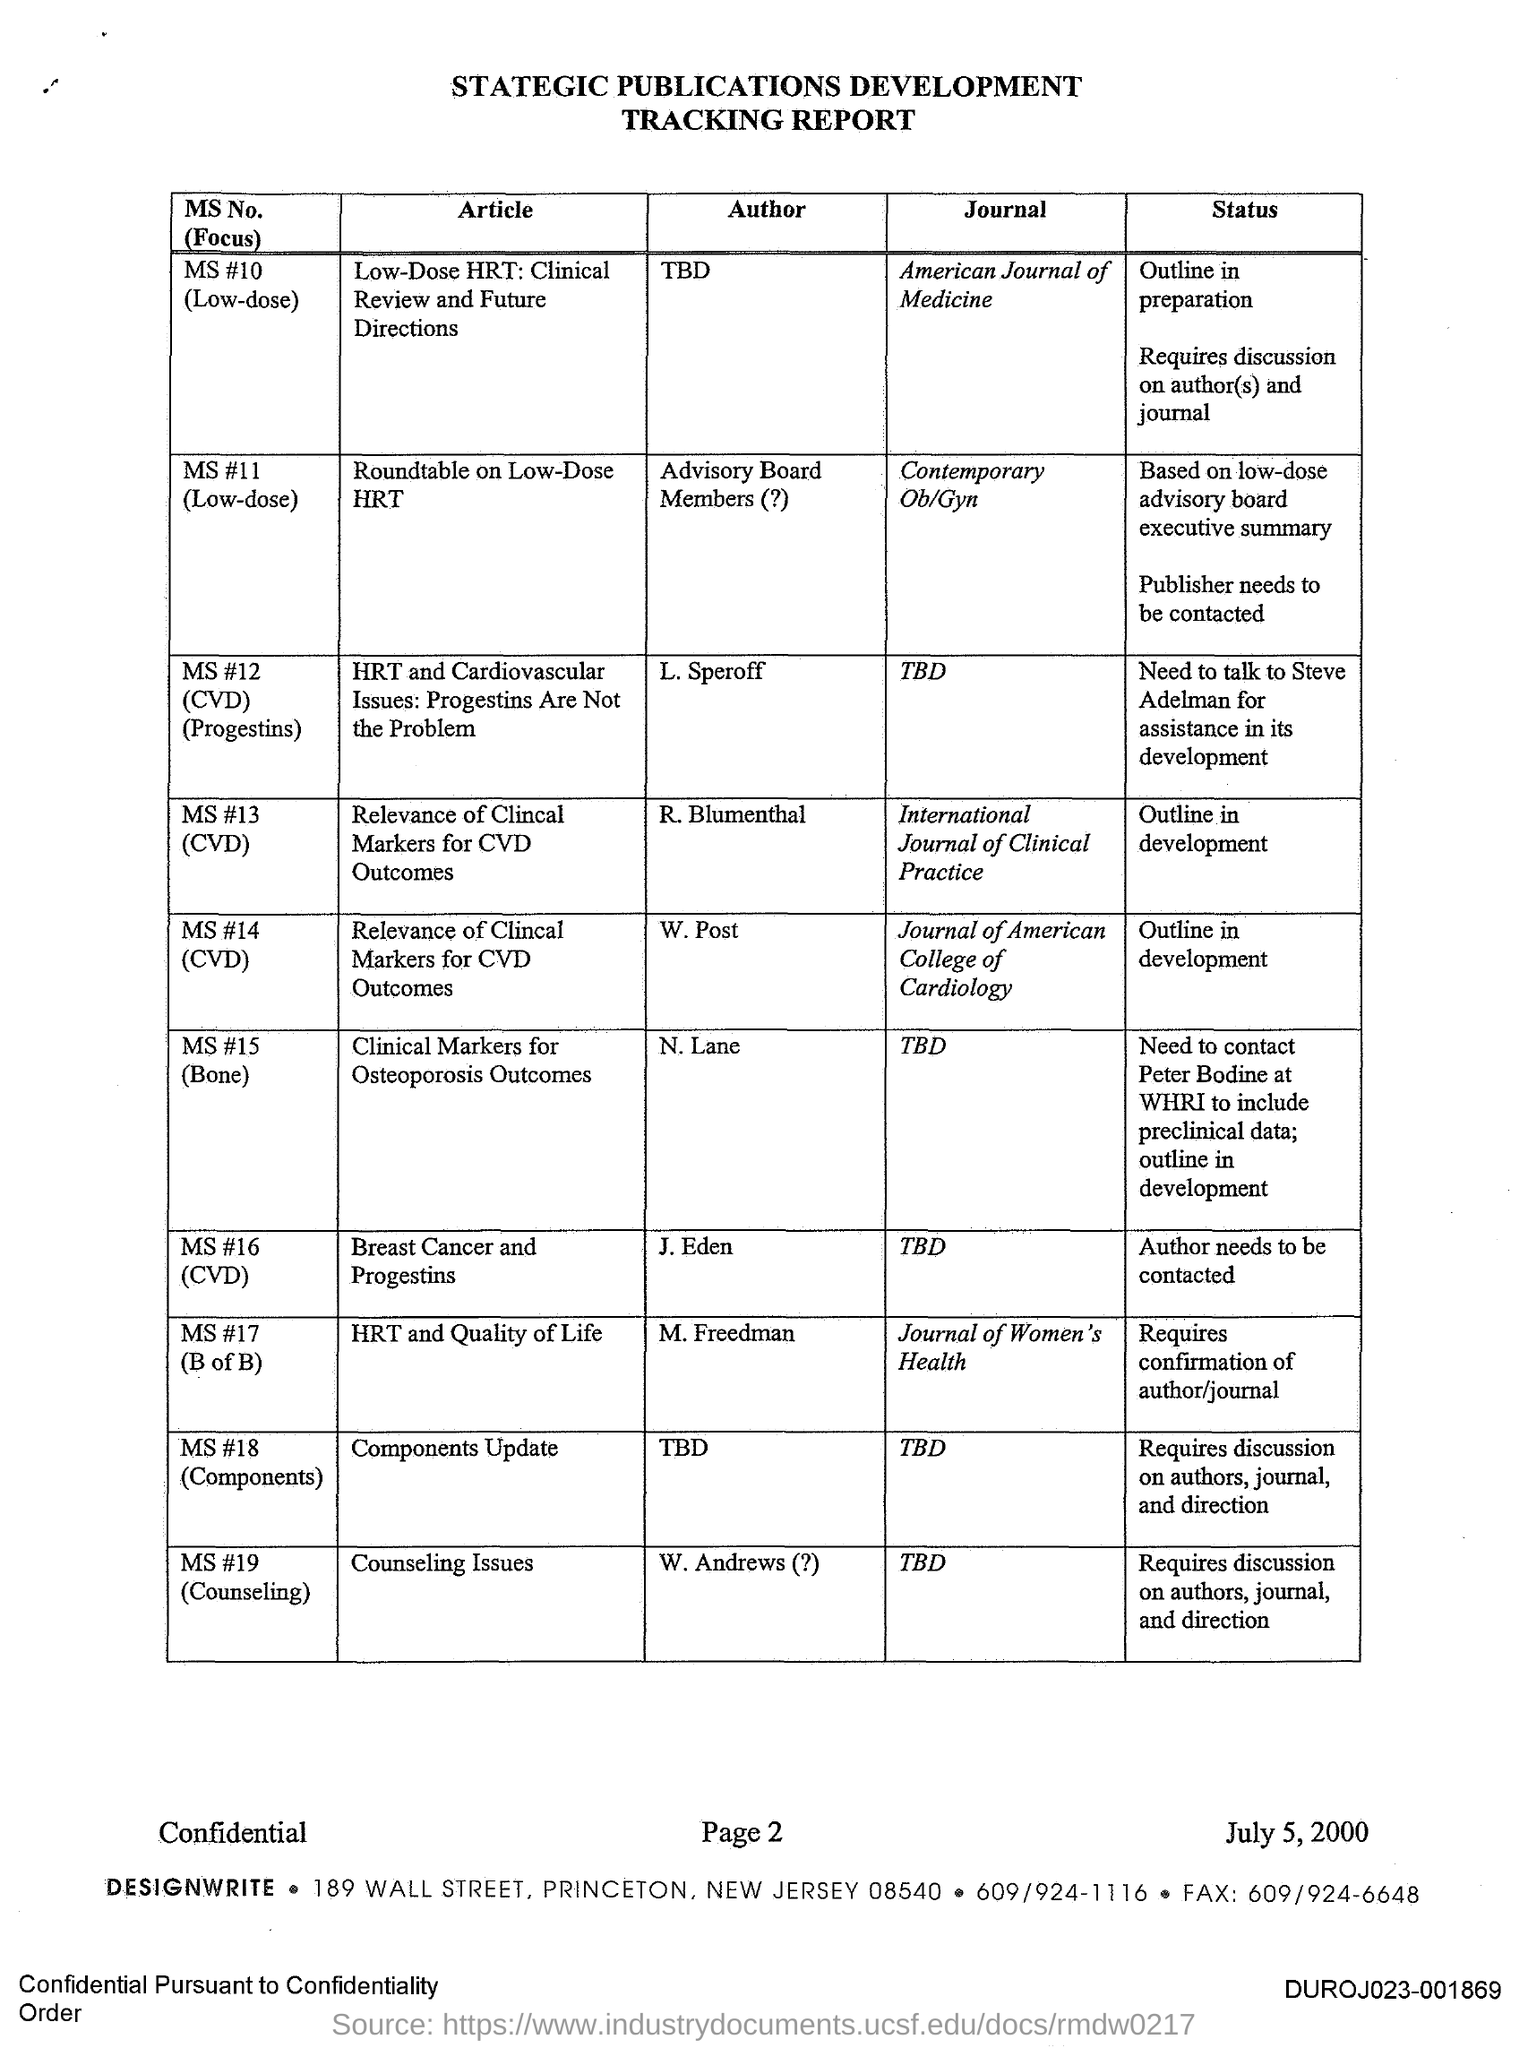What is the status of the article 'Breast Cancer and Progestins'? The article 'Breast Cancer and Progestins', authored by J. Eden, is marked 'TBD' for both the journal and the status. This indicates that the specific journal for publication has not been decided yet and that further actions such as contacting the author are necessary for advancing the publication process. 